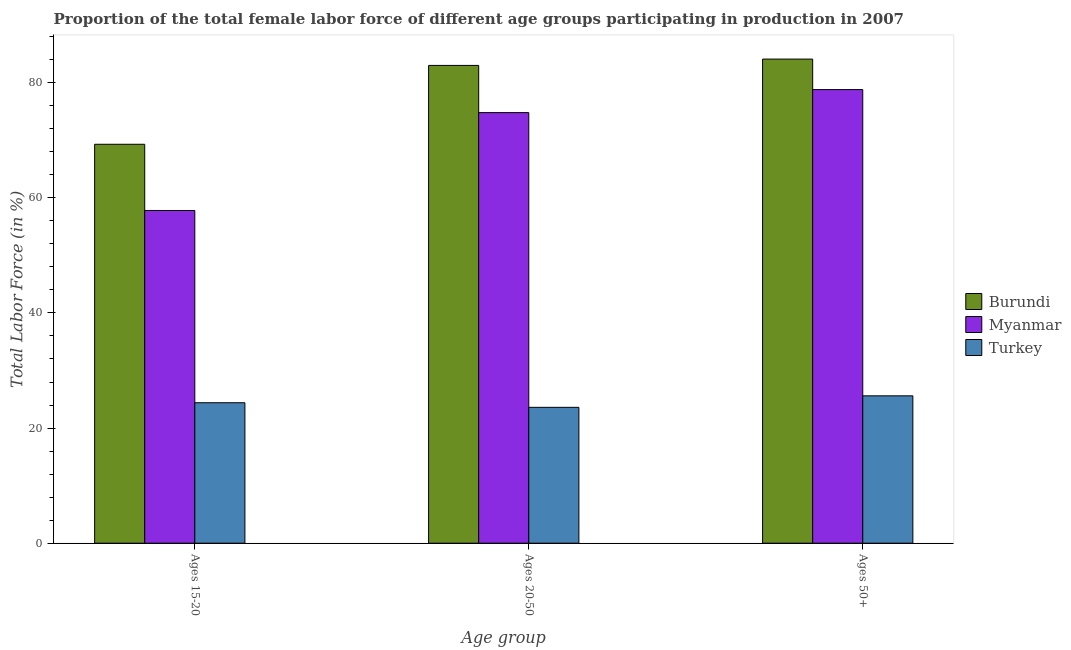Are the number of bars on each tick of the X-axis equal?
Your response must be concise. Yes. How many bars are there on the 2nd tick from the left?
Offer a very short reply. 3. What is the label of the 3rd group of bars from the left?
Your response must be concise. Ages 50+. What is the percentage of female labor force within the age group 15-20 in Myanmar?
Provide a short and direct response. 57.8. Across all countries, what is the maximum percentage of female labor force above age 50?
Your response must be concise. 84.1. Across all countries, what is the minimum percentage of female labor force within the age group 20-50?
Offer a very short reply. 23.6. In which country was the percentage of female labor force above age 50 maximum?
Offer a very short reply. Burundi. What is the total percentage of female labor force above age 50 in the graph?
Provide a succinct answer. 188.5. What is the difference between the percentage of female labor force within the age group 20-50 in Turkey and that in Burundi?
Your answer should be very brief. -59.4. What is the difference between the percentage of female labor force above age 50 in Myanmar and the percentage of female labor force within the age group 15-20 in Turkey?
Make the answer very short. 54.4. What is the average percentage of female labor force above age 50 per country?
Give a very brief answer. 62.83. What is the difference between the percentage of female labor force within the age group 20-50 and percentage of female labor force within the age group 15-20 in Turkey?
Give a very brief answer. -0.8. What is the ratio of the percentage of female labor force within the age group 15-20 in Burundi to that in Myanmar?
Keep it short and to the point. 1.2. Is the difference between the percentage of female labor force within the age group 20-50 in Myanmar and Turkey greater than the difference between the percentage of female labor force within the age group 15-20 in Myanmar and Turkey?
Your answer should be very brief. Yes. What is the difference between the highest and the second highest percentage of female labor force within the age group 20-50?
Make the answer very short. 8.2. What is the difference between the highest and the lowest percentage of female labor force within the age group 15-20?
Keep it short and to the point. 44.9. In how many countries, is the percentage of female labor force within the age group 15-20 greater than the average percentage of female labor force within the age group 15-20 taken over all countries?
Give a very brief answer. 2. What does the 2nd bar from the right in Ages 20-50 represents?
Your response must be concise. Myanmar. Is it the case that in every country, the sum of the percentage of female labor force within the age group 15-20 and percentage of female labor force within the age group 20-50 is greater than the percentage of female labor force above age 50?
Your response must be concise. Yes. How many countries are there in the graph?
Make the answer very short. 3. What is the difference between two consecutive major ticks on the Y-axis?
Keep it short and to the point. 20. Are the values on the major ticks of Y-axis written in scientific E-notation?
Your answer should be very brief. No. Does the graph contain any zero values?
Ensure brevity in your answer.  No. Does the graph contain grids?
Provide a succinct answer. No. How are the legend labels stacked?
Make the answer very short. Vertical. What is the title of the graph?
Ensure brevity in your answer.  Proportion of the total female labor force of different age groups participating in production in 2007. Does "Timor-Leste" appear as one of the legend labels in the graph?
Offer a very short reply. No. What is the label or title of the X-axis?
Ensure brevity in your answer.  Age group. What is the label or title of the Y-axis?
Offer a very short reply. Total Labor Force (in %). What is the Total Labor Force (in %) in Burundi in Ages 15-20?
Provide a short and direct response. 69.3. What is the Total Labor Force (in %) in Myanmar in Ages 15-20?
Ensure brevity in your answer.  57.8. What is the Total Labor Force (in %) of Turkey in Ages 15-20?
Make the answer very short. 24.4. What is the Total Labor Force (in %) in Burundi in Ages 20-50?
Provide a short and direct response. 83. What is the Total Labor Force (in %) in Myanmar in Ages 20-50?
Give a very brief answer. 74.8. What is the Total Labor Force (in %) in Turkey in Ages 20-50?
Your answer should be very brief. 23.6. What is the Total Labor Force (in %) in Burundi in Ages 50+?
Your answer should be compact. 84.1. What is the Total Labor Force (in %) of Myanmar in Ages 50+?
Make the answer very short. 78.8. What is the Total Labor Force (in %) in Turkey in Ages 50+?
Keep it short and to the point. 25.6. Across all Age group, what is the maximum Total Labor Force (in %) of Burundi?
Your response must be concise. 84.1. Across all Age group, what is the maximum Total Labor Force (in %) in Myanmar?
Give a very brief answer. 78.8. Across all Age group, what is the maximum Total Labor Force (in %) of Turkey?
Your answer should be very brief. 25.6. Across all Age group, what is the minimum Total Labor Force (in %) in Burundi?
Your response must be concise. 69.3. Across all Age group, what is the minimum Total Labor Force (in %) in Myanmar?
Your answer should be compact. 57.8. Across all Age group, what is the minimum Total Labor Force (in %) of Turkey?
Offer a terse response. 23.6. What is the total Total Labor Force (in %) of Burundi in the graph?
Offer a very short reply. 236.4. What is the total Total Labor Force (in %) in Myanmar in the graph?
Make the answer very short. 211.4. What is the total Total Labor Force (in %) in Turkey in the graph?
Your answer should be very brief. 73.6. What is the difference between the Total Labor Force (in %) of Burundi in Ages 15-20 and that in Ages 20-50?
Give a very brief answer. -13.7. What is the difference between the Total Labor Force (in %) in Burundi in Ages 15-20 and that in Ages 50+?
Provide a succinct answer. -14.8. What is the difference between the Total Labor Force (in %) in Myanmar in Ages 15-20 and that in Ages 50+?
Make the answer very short. -21. What is the difference between the Total Labor Force (in %) in Myanmar in Ages 20-50 and that in Ages 50+?
Make the answer very short. -4. What is the difference between the Total Labor Force (in %) in Turkey in Ages 20-50 and that in Ages 50+?
Your answer should be very brief. -2. What is the difference between the Total Labor Force (in %) in Burundi in Ages 15-20 and the Total Labor Force (in %) in Myanmar in Ages 20-50?
Provide a short and direct response. -5.5. What is the difference between the Total Labor Force (in %) of Burundi in Ages 15-20 and the Total Labor Force (in %) of Turkey in Ages 20-50?
Offer a very short reply. 45.7. What is the difference between the Total Labor Force (in %) of Myanmar in Ages 15-20 and the Total Labor Force (in %) of Turkey in Ages 20-50?
Your answer should be compact. 34.2. What is the difference between the Total Labor Force (in %) of Burundi in Ages 15-20 and the Total Labor Force (in %) of Myanmar in Ages 50+?
Your answer should be very brief. -9.5. What is the difference between the Total Labor Force (in %) of Burundi in Ages 15-20 and the Total Labor Force (in %) of Turkey in Ages 50+?
Give a very brief answer. 43.7. What is the difference between the Total Labor Force (in %) in Myanmar in Ages 15-20 and the Total Labor Force (in %) in Turkey in Ages 50+?
Give a very brief answer. 32.2. What is the difference between the Total Labor Force (in %) of Burundi in Ages 20-50 and the Total Labor Force (in %) of Myanmar in Ages 50+?
Your answer should be compact. 4.2. What is the difference between the Total Labor Force (in %) of Burundi in Ages 20-50 and the Total Labor Force (in %) of Turkey in Ages 50+?
Your answer should be compact. 57.4. What is the difference between the Total Labor Force (in %) in Myanmar in Ages 20-50 and the Total Labor Force (in %) in Turkey in Ages 50+?
Ensure brevity in your answer.  49.2. What is the average Total Labor Force (in %) of Burundi per Age group?
Your response must be concise. 78.8. What is the average Total Labor Force (in %) in Myanmar per Age group?
Provide a short and direct response. 70.47. What is the average Total Labor Force (in %) of Turkey per Age group?
Your answer should be compact. 24.53. What is the difference between the Total Labor Force (in %) of Burundi and Total Labor Force (in %) of Myanmar in Ages 15-20?
Ensure brevity in your answer.  11.5. What is the difference between the Total Labor Force (in %) in Burundi and Total Labor Force (in %) in Turkey in Ages 15-20?
Your answer should be compact. 44.9. What is the difference between the Total Labor Force (in %) in Myanmar and Total Labor Force (in %) in Turkey in Ages 15-20?
Make the answer very short. 33.4. What is the difference between the Total Labor Force (in %) in Burundi and Total Labor Force (in %) in Myanmar in Ages 20-50?
Offer a terse response. 8.2. What is the difference between the Total Labor Force (in %) of Burundi and Total Labor Force (in %) of Turkey in Ages 20-50?
Offer a terse response. 59.4. What is the difference between the Total Labor Force (in %) in Myanmar and Total Labor Force (in %) in Turkey in Ages 20-50?
Your response must be concise. 51.2. What is the difference between the Total Labor Force (in %) of Burundi and Total Labor Force (in %) of Myanmar in Ages 50+?
Your response must be concise. 5.3. What is the difference between the Total Labor Force (in %) in Burundi and Total Labor Force (in %) in Turkey in Ages 50+?
Your response must be concise. 58.5. What is the difference between the Total Labor Force (in %) of Myanmar and Total Labor Force (in %) of Turkey in Ages 50+?
Your answer should be very brief. 53.2. What is the ratio of the Total Labor Force (in %) in Burundi in Ages 15-20 to that in Ages 20-50?
Make the answer very short. 0.83. What is the ratio of the Total Labor Force (in %) of Myanmar in Ages 15-20 to that in Ages 20-50?
Your answer should be very brief. 0.77. What is the ratio of the Total Labor Force (in %) in Turkey in Ages 15-20 to that in Ages 20-50?
Provide a succinct answer. 1.03. What is the ratio of the Total Labor Force (in %) in Burundi in Ages 15-20 to that in Ages 50+?
Offer a terse response. 0.82. What is the ratio of the Total Labor Force (in %) of Myanmar in Ages 15-20 to that in Ages 50+?
Offer a terse response. 0.73. What is the ratio of the Total Labor Force (in %) in Turkey in Ages 15-20 to that in Ages 50+?
Your answer should be very brief. 0.95. What is the ratio of the Total Labor Force (in %) of Burundi in Ages 20-50 to that in Ages 50+?
Provide a succinct answer. 0.99. What is the ratio of the Total Labor Force (in %) of Myanmar in Ages 20-50 to that in Ages 50+?
Give a very brief answer. 0.95. What is the ratio of the Total Labor Force (in %) in Turkey in Ages 20-50 to that in Ages 50+?
Provide a short and direct response. 0.92. What is the difference between the highest and the second highest Total Labor Force (in %) in Burundi?
Offer a terse response. 1.1. What is the difference between the highest and the lowest Total Labor Force (in %) in Myanmar?
Provide a succinct answer. 21. 